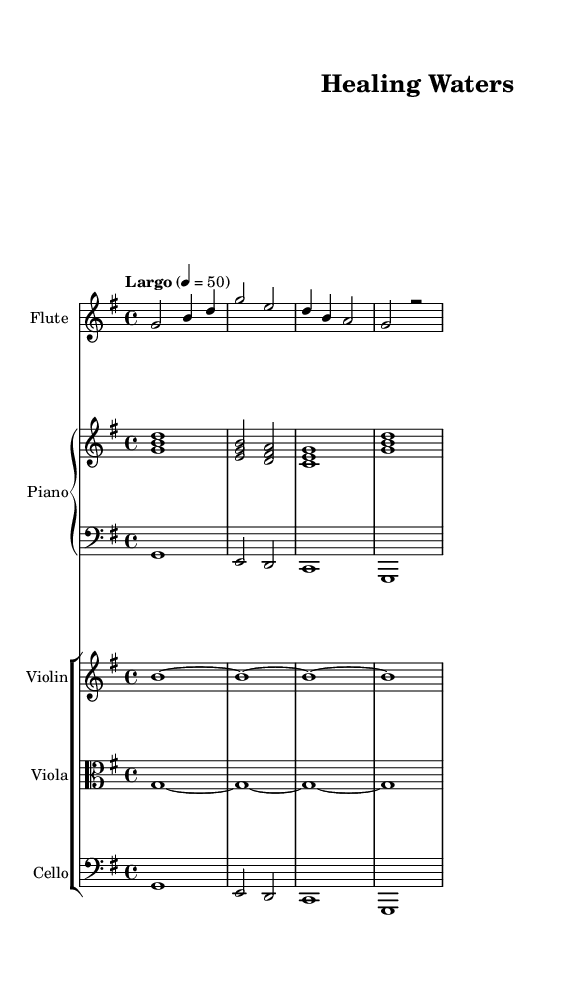What is the key signature of this music? The key signature shows one sharp, which indicates that the music is in G major.
Answer: G major What is the time signature of this music? The time signature is indicated at the beginning of the score as 4/4, meaning there are four beats in each measure.
Answer: 4/4 What is the tempo marking for this piece? The tempo marking is indicated as "Largo," which suggests a slow and broad tempo.
Answer: Largo Which instruments are included in this score? The score contains flute, violin, viola, cello, and piano. This can be identified from the labeled staves at the beginning of the music.
Answer: Flute, violin, viola, cello, piano How many measures are there in the flute part? The flute part has four measures, as counted by the separations in the notation.
Answer: 4 What note value is used for the first measure in the piano upper staff? The first measure in the piano upper staff contains a whole note, which is represented by a single note on the staff.
Answer: Whole note What is the main mood suggested by the tempo and instrumentation of this piece? The piece’s slow tempo (Largo) combined with soft instrumental choices suggests a calming and soothing mood typical of relaxation music.
Answer: Calming 